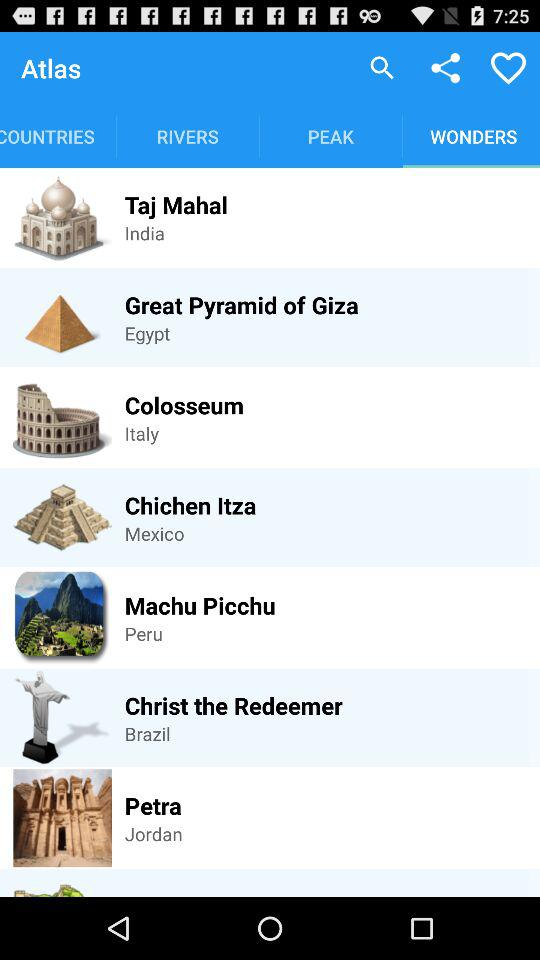Where is the Taj Mahal? The Taj Mahal is in India. 